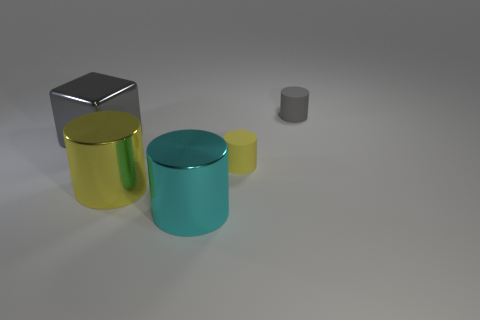What might be the function of these objects in real life? The objects appear to be simplistic and abstract; they don't have distinct features that indicate a specific real-life function. They could be interpreted as containers or purely decorative elements, given their cylinder and cube shapes. However, without additional context or features, their exact purposes are left to the imagination. 